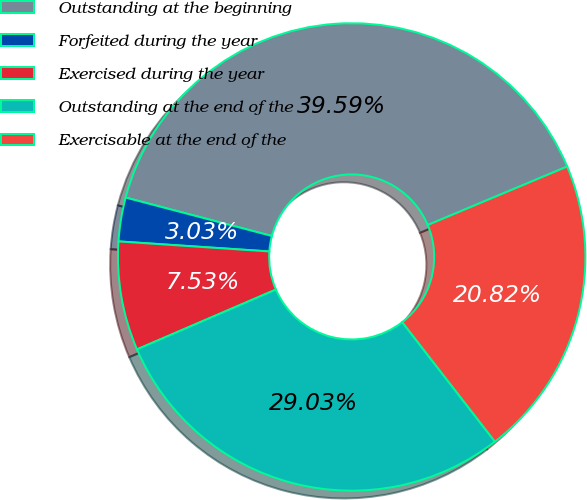Convert chart. <chart><loc_0><loc_0><loc_500><loc_500><pie_chart><fcel>Outstanding at the beginning<fcel>Forfeited during the year<fcel>Exercised during the year<fcel>Outstanding at the end of the<fcel>Exercisable at the end of the<nl><fcel>39.59%<fcel>3.03%<fcel>7.53%<fcel>29.03%<fcel>20.82%<nl></chart> 